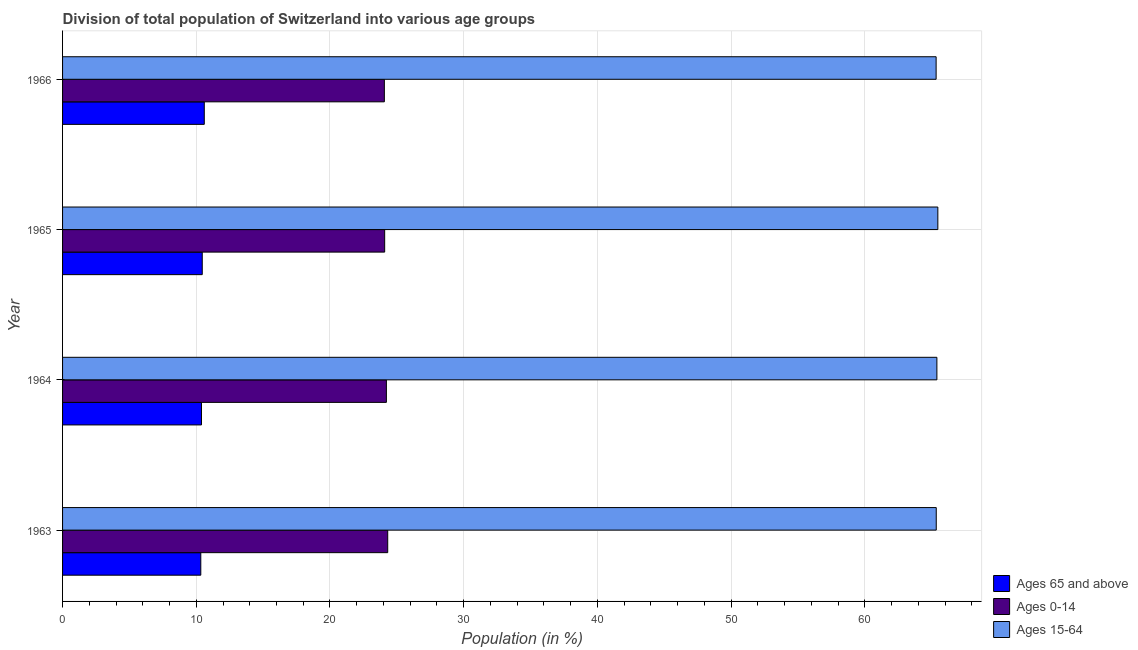How many different coloured bars are there?
Make the answer very short. 3. How many groups of bars are there?
Offer a very short reply. 4. Are the number of bars on each tick of the Y-axis equal?
Keep it short and to the point. Yes. How many bars are there on the 3rd tick from the top?
Give a very brief answer. 3. How many bars are there on the 3rd tick from the bottom?
Your response must be concise. 3. What is the label of the 3rd group of bars from the top?
Make the answer very short. 1964. In how many cases, is the number of bars for a given year not equal to the number of legend labels?
Your answer should be compact. 0. What is the percentage of population within the age-group 0-14 in 1965?
Provide a short and direct response. 24.09. Across all years, what is the maximum percentage of population within the age-group of 65 and above?
Your response must be concise. 10.6. Across all years, what is the minimum percentage of population within the age-group 15-64?
Your answer should be compact. 65.33. In which year was the percentage of population within the age-group 15-64 minimum?
Offer a very short reply. 1966. What is the total percentage of population within the age-group 0-14 in the graph?
Your answer should be very brief. 96.69. What is the difference between the percentage of population within the age-group 0-14 in 1963 and that in 1965?
Ensure brevity in your answer.  0.23. What is the difference between the percentage of population within the age-group 0-14 in 1966 and the percentage of population within the age-group 15-64 in 1965?
Your answer should be compact. -41.39. What is the average percentage of population within the age-group 0-14 per year?
Offer a terse response. 24.17. In the year 1966, what is the difference between the percentage of population within the age-group of 65 and above and percentage of population within the age-group 15-64?
Provide a succinct answer. -54.73. In how many years, is the percentage of population within the age-group 0-14 greater than 26 %?
Give a very brief answer. 0. What is the ratio of the percentage of population within the age-group 15-64 in 1963 to that in 1966?
Make the answer very short. 1. Is the percentage of population within the age-group 15-64 in 1963 less than that in 1966?
Make the answer very short. No. Is the difference between the percentage of population within the age-group 15-64 in 1964 and 1966 greater than the difference between the percentage of population within the age-group 0-14 in 1964 and 1966?
Ensure brevity in your answer.  No. What is the difference between the highest and the lowest percentage of population within the age-group 15-64?
Ensure brevity in your answer.  0.13. In how many years, is the percentage of population within the age-group of 65 and above greater than the average percentage of population within the age-group of 65 and above taken over all years?
Give a very brief answer. 2. Is the sum of the percentage of population within the age-group 15-64 in 1964 and 1965 greater than the maximum percentage of population within the age-group of 65 and above across all years?
Your answer should be very brief. Yes. What does the 2nd bar from the top in 1964 represents?
Offer a very short reply. Ages 0-14. What does the 1st bar from the bottom in 1964 represents?
Ensure brevity in your answer.  Ages 65 and above. How many years are there in the graph?
Ensure brevity in your answer.  4. Are the values on the major ticks of X-axis written in scientific E-notation?
Your answer should be very brief. No. Does the graph contain grids?
Provide a succinct answer. Yes. Where does the legend appear in the graph?
Offer a terse response. Bottom right. How many legend labels are there?
Your answer should be very brief. 3. What is the title of the graph?
Your answer should be very brief. Division of total population of Switzerland into various age groups
. Does "Social insurance" appear as one of the legend labels in the graph?
Offer a terse response. No. What is the label or title of the Y-axis?
Provide a succinct answer. Year. What is the Population (in %) of Ages 65 and above in 1963?
Provide a succinct answer. 10.34. What is the Population (in %) in Ages 0-14 in 1963?
Offer a terse response. 24.32. What is the Population (in %) in Ages 15-64 in 1963?
Your answer should be compact. 65.34. What is the Population (in %) of Ages 65 and above in 1964?
Your response must be concise. 10.39. What is the Population (in %) of Ages 0-14 in 1964?
Your response must be concise. 24.22. What is the Population (in %) in Ages 15-64 in 1964?
Make the answer very short. 65.39. What is the Population (in %) in Ages 65 and above in 1965?
Offer a terse response. 10.45. What is the Population (in %) of Ages 0-14 in 1965?
Your answer should be very brief. 24.09. What is the Population (in %) of Ages 15-64 in 1965?
Provide a short and direct response. 65.46. What is the Population (in %) of Ages 65 and above in 1966?
Give a very brief answer. 10.6. What is the Population (in %) in Ages 0-14 in 1966?
Your response must be concise. 24.07. What is the Population (in %) of Ages 15-64 in 1966?
Ensure brevity in your answer.  65.33. Across all years, what is the maximum Population (in %) of Ages 65 and above?
Offer a terse response. 10.6. Across all years, what is the maximum Population (in %) in Ages 0-14?
Provide a short and direct response. 24.32. Across all years, what is the maximum Population (in %) of Ages 15-64?
Provide a short and direct response. 65.46. Across all years, what is the minimum Population (in %) in Ages 65 and above?
Ensure brevity in your answer.  10.34. Across all years, what is the minimum Population (in %) in Ages 0-14?
Your response must be concise. 24.07. Across all years, what is the minimum Population (in %) in Ages 15-64?
Offer a terse response. 65.33. What is the total Population (in %) in Ages 65 and above in the graph?
Provide a short and direct response. 41.77. What is the total Population (in %) in Ages 0-14 in the graph?
Your answer should be very brief. 96.69. What is the total Population (in %) in Ages 15-64 in the graph?
Ensure brevity in your answer.  261.53. What is the difference between the Population (in %) of Ages 65 and above in 1963 and that in 1964?
Your response must be concise. -0.05. What is the difference between the Population (in %) in Ages 15-64 in 1963 and that in 1964?
Your answer should be very brief. -0.05. What is the difference between the Population (in %) of Ages 65 and above in 1963 and that in 1965?
Your answer should be compact. -0.11. What is the difference between the Population (in %) of Ages 0-14 in 1963 and that in 1965?
Offer a very short reply. 0.23. What is the difference between the Population (in %) of Ages 15-64 in 1963 and that in 1965?
Make the answer very short. -0.12. What is the difference between the Population (in %) in Ages 65 and above in 1963 and that in 1966?
Keep it short and to the point. -0.26. What is the difference between the Population (in %) of Ages 0-14 in 1963 and that in 1966?
Provide a short and direct response. 0.25. What is the difference between the Population (in %) of Ages 15-64 in 1963 and that in 1966?
Your answer should be very brief. 0.01. What is the difference between the Population (in %) in Ages 65 and above in 1964 and that in 1965?
Provide a succinct answer. -0.06. What is the difference between the Population (in %) of Ages 0-14 in 1964 and that in 1965?
Offer a very short reply. 0.13. What is the difference between the Population (in %) in Ages 15-64 in 1964 and that in 1965?
Your response must be concise. -0.07. What is the difference between the Population (in %) of Ages 65 and above in 1964 and that in 1966?
Give a very brief answer. -0.21. What is the difference between the Population (in %) in Ages 0-14 in 1964 and that in 1966?
Provide a succinct answer. 0.15. What is the difference between the Population (in %) of Ages 15-64 in 1964 and that in 1966?
Offer a very short reply. 0.06. What is the difference between the Population (in %) in Ages 65 and above in 1965 and that in 1966?
Provide a succinct answer. -0.15. What is the difference between the Population (in %) in Ages 0-14 in 1965 and that in 1966?
Offer a very short reply. 0.02. What is the difference between the Population (in %) of Ages 15-64 in 1965 and that in 1966?
Your answer should be compact. 0.13. What is the difference between the Population (in %) in Ages 65 and above in 1963 and the Population (in %) in Ages 0-14 in 1964?
Make the answer very short. -13.88. What is the difference between the Population (in %) of Ages 65 and above in 1963 and the Population (in %) of Ages 15-64 in 1964?
Your answer should be very brief. -55.05. What is the difference between the Population (in %) in Ages 0-14 in 1963 and the Population (in %) in Ages 15-64 in 1964?
Keep it short and to the point. -41.07. What is the difference between the Population (in %) of Ages 65 and above in 1963 and the Population (in %) of Ages 0-14 in 1965?
Give a very brief answer. -13.75. What is the difference between the Population (in %) of Ages 65 and above in 1963 and the Population (in %) of Ages 15-64 in 1965?
Ensure brevity in your answer.  -55.12. What is the difference between the Population (in %) in Ages 0-14 in 1963 and the Population (in %) in Ages 15-64 in 1965?
Keep it short and to the point. -41.14. What is the difference between the Population (in %) of Ages 65 and above in 1963 and the Population (in %) of Ages 0-14 in 1966?
Provide a succinct answer. -13.73. What is the difference between the Population (in %) in Ages 65 and above in 1963 and the Population (in %) in Ages 15-64 in 1966?
Keep it short and to the point. -55. What is the difference between the Population (in %) of Ages 0-14 in 1963 and the Population (in %) of Ages 15-64 in 1966?
Your answer should be very brief. -41.02. What is the difference between the Population (in %) in Ages 65 and above in 1964 and the Population (in %) in Ages 0-14 in 1965?
Provide a short and direct response. -13.7. What is the difference between the Population (in %) of Ages 65 and above in 1964 and the Population (in %) of Ages 15-64 in 1965?
Offer a very short reply. -55.07. What is the difference between the Population (in %) in Ages 0-14 in 1964 and the Population (in %) in Ages 15-64 in 1965?
Provide a short and direct response. -41.24. What is the difference between the Population (in %) of Ages 65 and above in 1964 and the Population (in %) of Ages 0-14 in 1966?
Ensure brevity in your answer.  -13.68. What is the difference between the Population (in %) in Ages 65 and above in 1964 and the Population (in %) in Ages 15-64 in 1966?
Your answer should be very brief. -54.94. What is the difference between the Population (in %) of Ages 0-14 in 1964 and the Population (in %) of Ages 15-64 in 1966?
Ensure brevity in your answer.  -41.12. What is the difference between the Population (in %) of Ages 65 and above in 1965 and the Population (in %) of Ages 0-14 in 1966?
Provide a succinct answer. -13.62. What is the difference between the Population (in %) of Ages 65 and above in 1965 and the Population (in %) of Ages 15-64 in 1966?
Make the answer very short. -54.89. What is the difference between the Population (in %) of Ages 0-14 in 1965 and the Population (in %) of Ages 15-64 in 1966?
Offer a terse response. -41.24. What is the average Population (in %) in Ages 65 and above per year?
Your answer should be very brief. 10.44. What is the average Population (in %) of Ages 0-14 per year?
Offer a terse response. 24.17. What is the average Population (in %) in Ages 15-64 per year?
Your answer should be compact. 65.38. In the year 1963, what is the difference between the Population (in %) of Ages 65 and above and Population (in %) of Ages 0-14?
Make the answer very short. -13.98. In the year 1963, what is the difference between the Population (in %) of Ages 65 and above and Population (in %) of Ages 15-64?
Your response must be concise. -55.01. In the year 1963, what is the difference between the Population (in %) in Ages 0-14 and Population (in %) in Ages 15-64?
Your answer should be very brief. -41.02. In the year 1964, what is the difference between the Population (in %) of Ages 65 and above and Population (in %) of Ages 0-14?
Make the answer very short. -13.83. In the year 1964, what is the difference between the Population (in %) of Ages 65 and above and Population (in %) of Ages 15-64?
Give a very brief answer. -55. In the year 1964, what is the difference between the Population (in %) of Ages 0-14 and Population (in %) of Ages 15-64?
Your answer should be compact. -41.17. In the year 1965, what is the difference between the Population (in %) of Ages 65 and above and Population (in %) of Ages 0-14?
Keep it short and to the point. -13.64. In the year 1965, what is the difference between the Population (in %) in Ages 65 and above and Population (in %) in Ages 15-64?
Ensure brevity in your answer.  -55.01. In the year 1965, what is the difference between the Population (in %) in Ages 0-14 and Population (in %) in Ages 15-64?
Your answer should be very brief. -41.37. In the year 1966, what is the difference between the Population (in %) in Ages 65 and above and Population (in %) in Ages 0-14?
Offer a terse response. -13.47. In the year 1966, what is the difference between the Population (in %) in Ages 65 and above and Population (in %) in Ages 15-64?
Provide a short and direct response. -54.73. In the year 1966, what is the difference between the Population (in %) in Ages 0-14 and Population (in %) in Ages 15-64?
Make the answer very short. -41.27. What is the ratio of the Population (in %) of Ages 65 and above in 1963 to that in 1965?
Your answer should be compact. 0.99. What is the ratio of the Population (in %) in Ages 0-14 in 1963 to that in 1965?
Give a very brief answer. 1.01. What is the ratio of the Population (in %) of Ages 15-64 in 1963 to that in 1965?
Ensure brevity in your answer.  1. What is the ratio of the Population (in %) in Ages 65 and above in 1963 to that in 1966?
Your response must be concise. 0.98. What is the ratio of the Population (in %) of Ages 0-14 in 1963 to that in 1966?
Offer a very short reply. 1.01. What is the ratio of the Population (in %) of Ages 15-64 in 1963 to that in 1966?
Offer a terse response. 1. What is the ratio of the Population (in %) of Ages 65 and above in 1964 to that in 1965?
Offer a terse response. 0.99. What is the ratio of the Population (in %) in Ages 15-64 in 1964 to that in 1965?
Your answer should be very brief. 1. What is the ratio of the Population (in %) in Ages 65 and above in 1964 to that in 1966?
Offer a very short reply. 0.98. What is the ratio of the Population (in %) of Ages 65 and above in 1965 to that in 1966?
Offer a very short reply. 0.99. What is the ratio of the Population (in %) in Ages 0-14 in 1965 to that in 1966?
Ensure brevity in your answer.  1. What is the ratio of the Population (in %) in Ages 15-64 in 1965 to that in 1966?
Provide a short and direct response. 1. What is the difference between the highest and the second highest Population (in %) of Ages 65 and above?
Provide a short and direct response. 0.15. What is the difference between the highest and the second highest Population (in %) of Ages 15-64?
Your response must be concise. 0.07. What is the difference between the highest and the lowest Population (in %) in Ages 65 and above?
Your response must be concise. 0.26. What is the difference between the highest and the lowest Population (in %) of Ages 0-14?
Offer a terse response. 0.25. What is the difference between the highest and the lowest Population (in %) in Ages 15-64?
Make the answer very short. 0.13. 